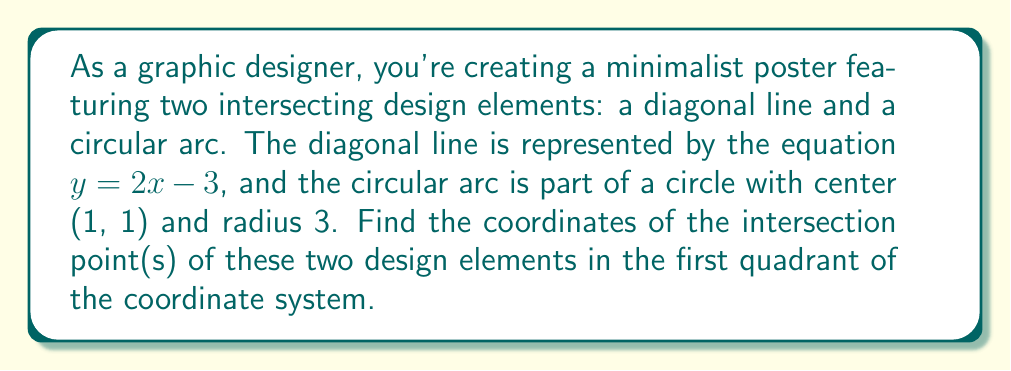Help me with this question. Let's approach this step-by-step:

1) The diagonal line is given by the equation:
   $y = 2x - 3$

2) The circle with center (1, 1) and radius 3 has the equation:
   $(x - 1)^2 + (y - 1)^2 = 3^2 = 9$

3) To find the intersection points, we need to solve these equations simultaneously. Let's substitute the equation of the line into the circle equation:

   $(x - 1)^2 + ((2x - 3) - 1)^2 = 9$

4) Simplify:
   $(x - 1)^2 + (2x - 4)^2 = 9$

5) Expand:
   $x^2 - 2x + 1 + 4x^2 - 16x + 16 = 9$

6) Combine like terms:
   $5x^2 - 18x + 8 = 0$

7) This is a quadratic equation. We can solve it using the quadratic formula:
   $x = \frac{-b \pm \sqrt{b^2 - 4ac}}{2a}$

   Where $a = 5$, $b = -18$, and $c = 8$

8) Substituting these values:
   $x = \frac{18 \pm \sqrt{(-18)^2 - 4(5)(8)}}{2(5)}$
   $= \frac{18 \pm \sqrt{324 - 160}}{10}$
   $= \frac{18 \pm \sqrt{164}}{10}$
   $= \frac{18 \pm 12.8062}{10}$

9) This gives us two solutions:
   $x_1 = \frac{18 + 12.8062}{10} = 3.08062$
   $x_2 = \frac{18 - 12.8062}{10} = 0.51938$

10) To find the corresponding y-values, we substitute these x-values into the equation of the line:
    For $x_1$: $y_1 = 2(3.08062) - 3 = 3.16124$
    For $x_2$: $y_2 = 2(0.51938) - 3 = -1.96124$

11) The question asks for the intersection point in the first quadrant, so we choose the point with positive x and y coordinates.
Answer: The intersection point of the diagonal line and the circular arc in the first quadrant is approximately (3.08, 3.16). 